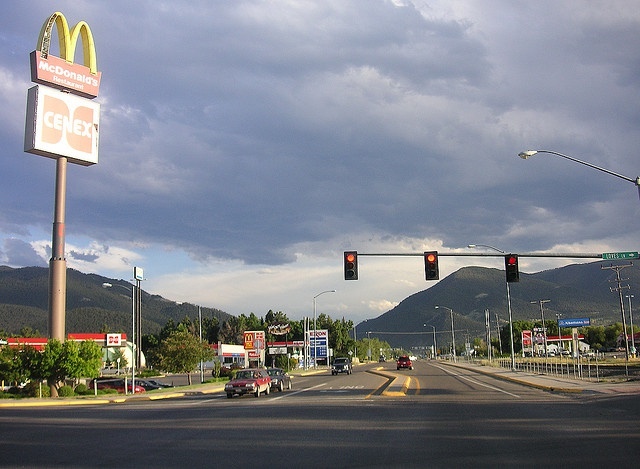Describe the objects in this image and their specific colors. I can see car in gray, black, brown, and maroon tones, car in gray, black, maroon, and olive tones, traffic light in gray, black, ivory, and maroon tones, traffic light in gray, black, and brown tones, and car in gray, black, and darkgray tones in this image. 